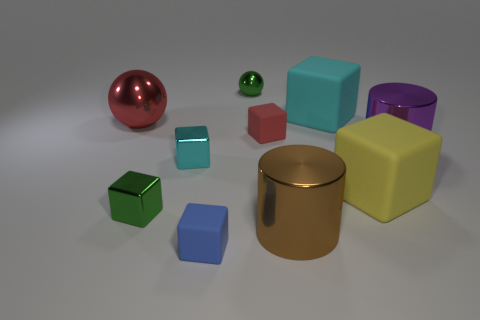Subtract 1 cubes. How many cubes are left? 5 Subtract all blue blocks. How many blocks are left? 5 Subtract all large cubes. How many cubes are left? 4 Subtract all purple cubes. Subtract all purple balls. How many cubes are left? 6 Subtract all blocks. How many objects are left? 4 Subtract 0 yellow cylinders. How many objects are left? 10 Subtract all green balls. Subtract all big red things. How many objects are left? 8 Add 9 large brown cylinders. How many large brown cylinders are left? 10 Add 4 tiny green metallic things. How many tiny green metallic things exist? 6 